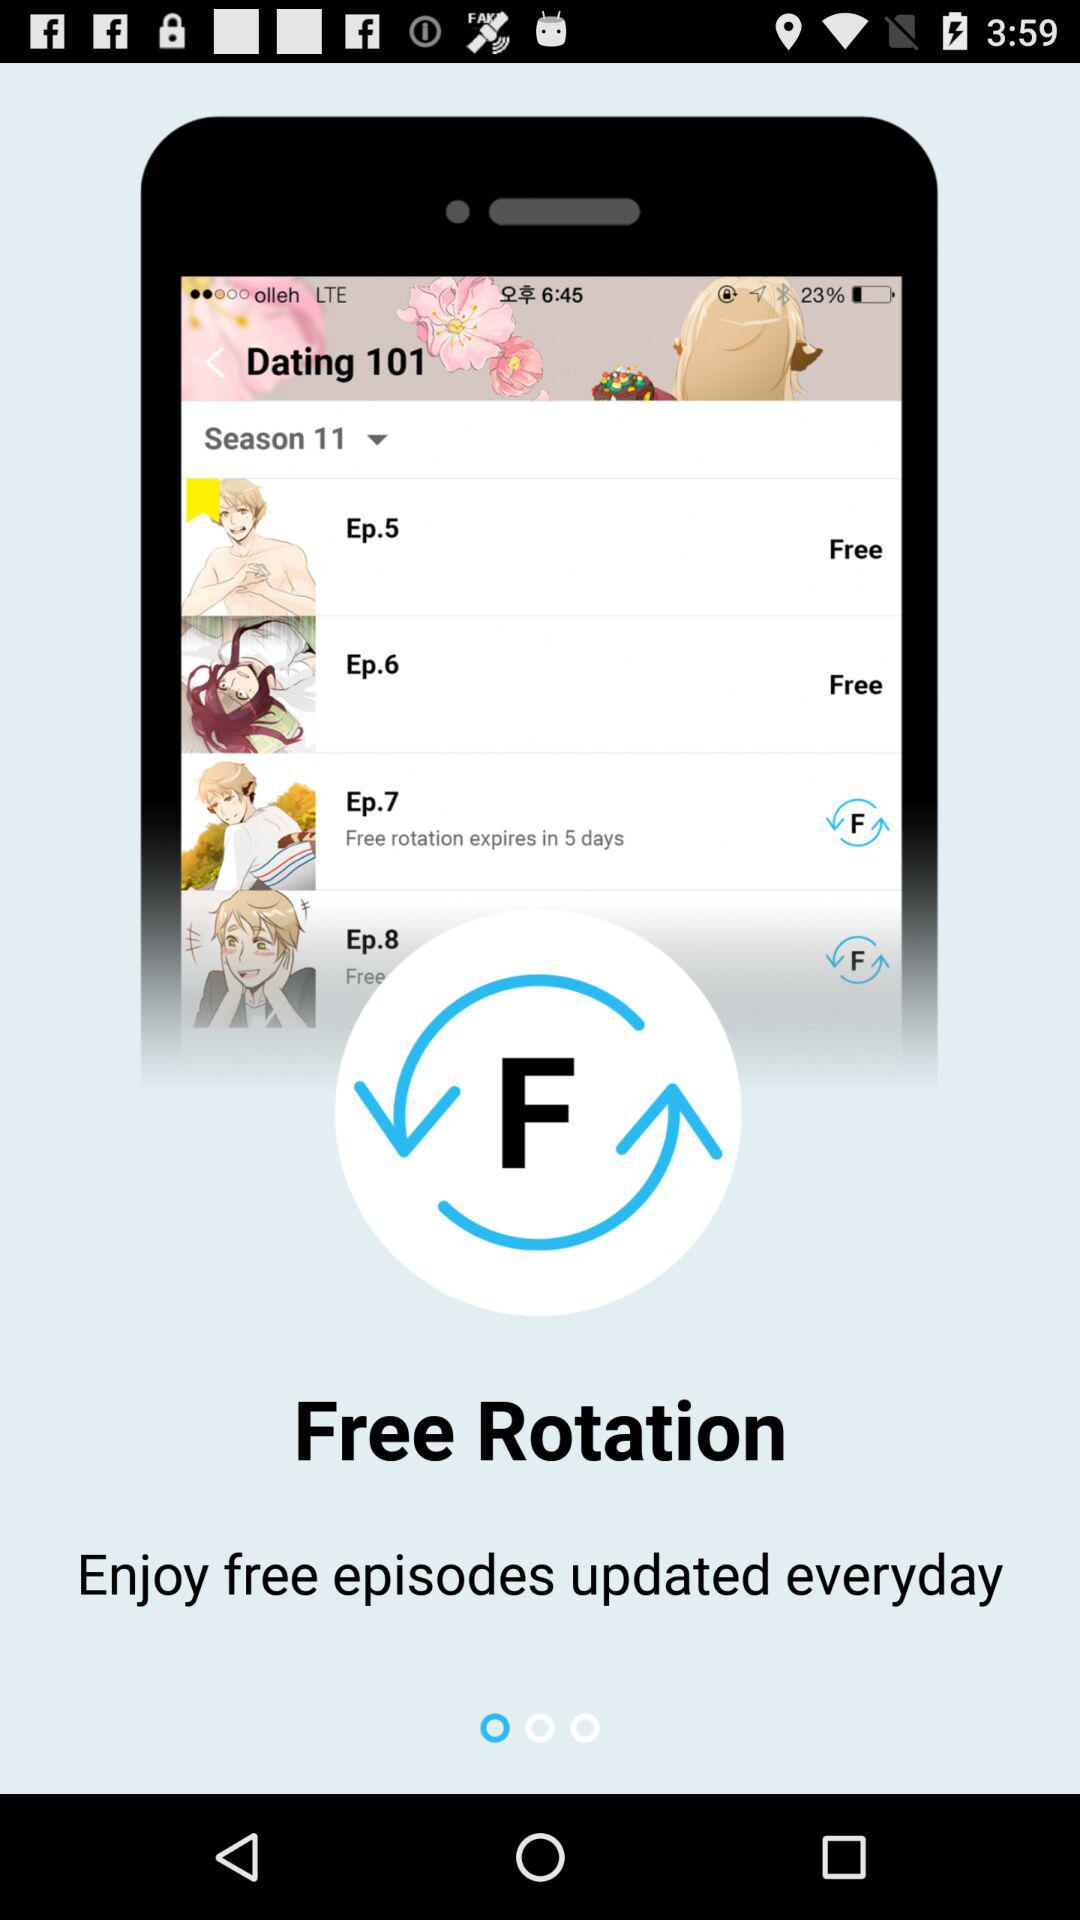What is the application name?
When the provided information is insufficient, respond with <no answer>. <no answer> 